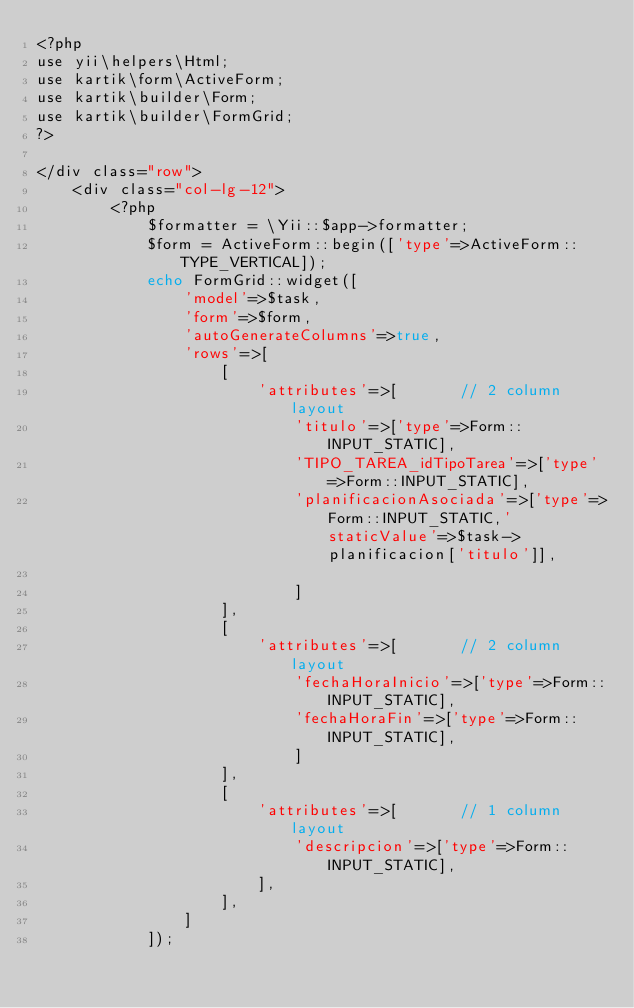<code> <loc_0><loc_0><loc_500><loc_500><_PHP_><?php 
use yii\helpers\Html;
use kartik\form\ActiveForm;
use kartik\builder\Form;
use kartik\builder\FormGrid;
?>

</div class="row">
    <div class="col-lg-12">
        <?php
            $formatter = \Yii::$app->formatter;
            $form = ActiveForm::begin(['type'=>ActiveForm::TYPE_VERTICAL]);
            echo FormGrid::widget([
                'model'=>$task,
                'form'=>$form,
                'autoGenerateColumns'=>true,
                'rows'=>[
                    [
                        'attributes'=>[       // 2 column layout
                            'titulo'=>['type'=>Form::INPUT_STATIC],
                            'TIPO_TAREA_idTipoTarea'=>['type'=>Form::INPUT_STATIC],
                            'planificacionAsociada'=>['type'=>Form::INPUT_STATIC,'staticValue'=>$task->planificacion['titulo']],
                            
                            ]
                    ],
                    [
                        'attributes'=>[       // 2 column layout
                            'fechaHoraInicio'=>['type'=>Form::INPUT_STATIC],
                            'fechaHoraFin'=>['type'=>Form::INPUT_STATIC],
                            ]
                    ],
                    [
                        'attributes'=>[       // 1 column layout
                            'descripcion'=>['type'=>Form::INPUT_STATIC],
                        ],
                    ],
                ]
            ]);</code> 